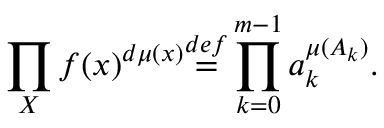Convert formula to latex. <formula><loc_0><loc_0><loc_500><loc_500>\prod _ { X } f ( x ) ^ { d \mu ( x ) } { \overset { d e f } { = } } \prod _ { k = 0 } ^ { m - 1 } a _ { k } ^ { \mu ( A _ { k } ) } .</formula> 